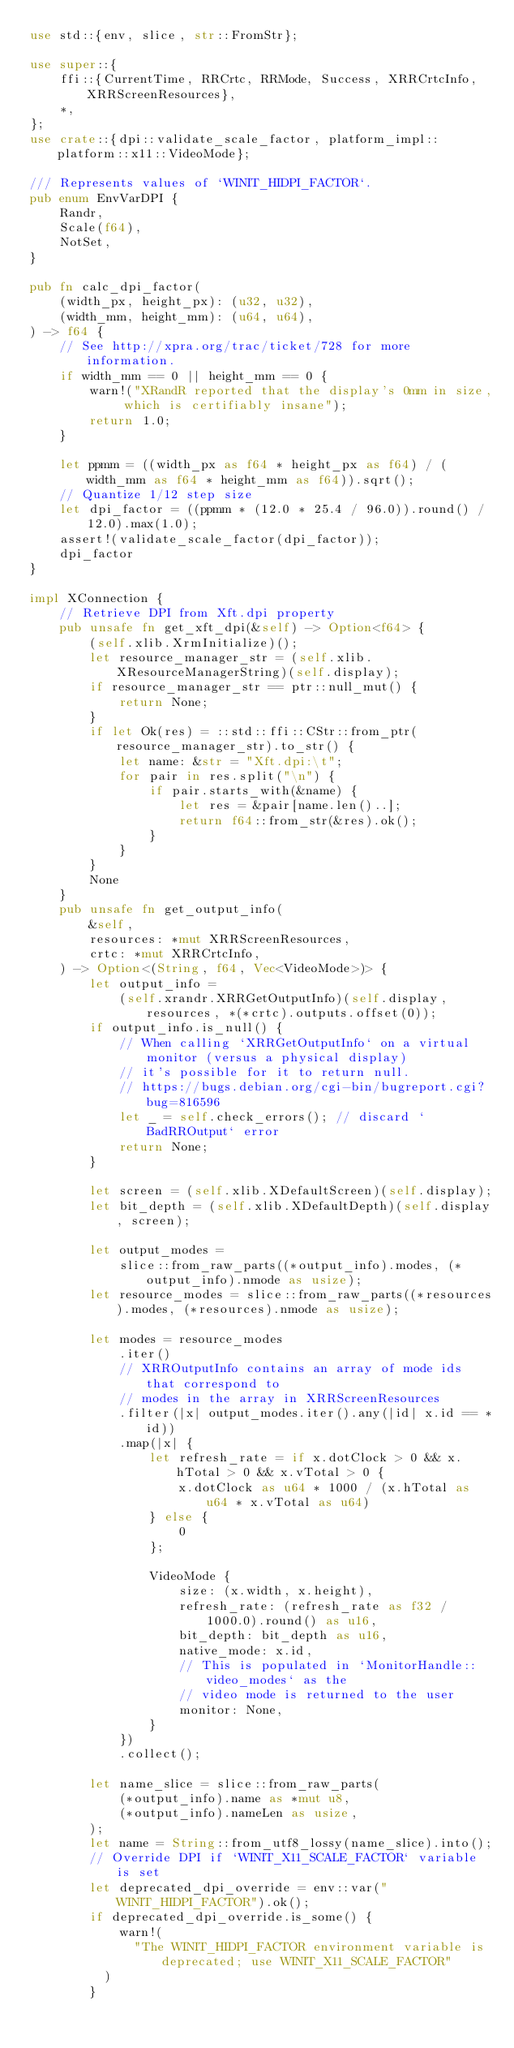<code> <loc_0><loc_0><loc_500><loc_500><_Rust_>use std::{env, slice, str::FromStr};

use super::{
    ffi::{CurrentTime, RRCrtc, RRMode, Success, XRRCrtcInfo, XRRScreenResources},
    *,
};
use crate::{dpi::validate_scale_factor, platform_impl::platform::x11::VideoMode};

/// Represents values of `WINIT_HIDPI_FACTOR`.
pub enum EnvVarDPI {
    Randr,
    Scale(f64),
    NotSet,
}

pub fn calc_dpi_factor(
    (width_px, height_px): (u32, u32),
    (width_mm, height_mm): (u64, u64),
) -> f64 {
    // See http://xpra.org/trac/ticket/728 for more information.
    if width_mm == 0 || height_mm == 0 {
        warn!("XRandR reported that the display's 0mm in size, which is certifiably insane");
        return 1.0;
    }

    let ppmm = ((width_px as f64 * height_px as f64) / (width_mm as f64 * height_mm as f64)).sqrt();
    // Quantize 1/12 step size
    let dpi_factor = ((ppmm * (12.0 * 25.4 / 96.0)).round() / 12.0).max(1.0);
    assert!(validate_scale_factor(dpi_factor));
    dpi_factor
}

impl XConnection {
    // Retrieve DPI from Xft.dpi property
    pub unsafe fn get_xft_dpi(&self) -> Option<f64> {
        (self.xlib.XrmInitialize)();
        let resource_manager_str = (self.xlib.XResourceManagerString)(self.display);
        if resource_manager_str == ptr::null_mut() {
            return None;
        }
        if let Ok(res) = ::std::ffi::CStr::from_ptr(resource_manager_str).to_str() {
            let name: &str = "Xft.dpi:\t";
            for pair in res.split("\n") {
                if pair.starts_with(&name) {
                    let res = &pair[name.len()..];
                    return f64::from_str(&res).ok();
                }
            }
        }
        None
    }
    pub unsafe fn get_output_info(
        &self,
        resources: *mut XRRScreenResources,
        crtc: *mut XRRCrtcInfo,
    ) -> Option<(String, f64, Vec<VideoMode>)> {
        let output_info =
            (self.xrandr.XRRGetOutputInfo)(self.display, resources, *(*crtc).outputs.offset(0));
        if output_info.is_null() {
            // When calling `XRRGetOutputInfo` on a virtual monitor (versus a physical display)
            // it's possible for it to return null.
            // https://bugs.debian.org/cgi-bin/bugreport.cgi?bug=816596
            let _ = self.check_errors(); // discard `BadRROutput` error
            return None;
        }

        let screen = (self.xlib.XDefaultScreen)(self.display);
        let bit_depth = (self.xlib.XDefaultDepth)(self.display, screen);

        let output_modes =
            slice::from_raw_parts((*output_info).modes, (*output_info).nmode as usize);
        let resource_modes = slice::from_raw_parts((*resources).modes, (*resources).nmode as usize);

        let modes = resource_modes
            .iter()
            // XRROutputInfo contains an array of mode ids that correspond to
            // modes in the array in XRRScreenResources
            .filter(|x| output_modes.iter().any(|id| x.id == *id))
            .map(|x| {
                let refresh_rate = if x.dotClock > 0 && x.hTotal > 0 && x.vTotal > 0 {
                    x.dotClock as u64 * 1000 / (x.hTotal as u64 * x.vTotal as u64)
                } else {
                    0
                };

                VideoMode {
                    size: (x.width, x.height),
                    refresh_rate: (refresh_rate as f32 / 1000.0).round() as u16,
                    bit_depth: bit_depth as u16,
                    native_mode: x.id,
                    // This is populated in `MonitorHandle::video_modes` as the
                    // video mode is returned to the user
                    monitor: None,
                }
            })
            .collect();

        let name_slice = slice::from_raw_parts(
            (*output_info).name as *mut u8,
            (*output_info).nameLen as usize,
        );
        let name = String::from_utf8_lossy(name_slice).into();
        // Override DPI if `WINIT_X11_SCALE_FACTOR` variable is set
        let deprecated_dpi_override = env::var("WINIT_HIDPI_FACTOR").ok();
        if deprecated_dpi_override.is_some() {
            warn!(
	            "The WINIT_HIDPI_FACTOR environment variable is deprecated; use WINIT_X11_SCALE_FACTOR"
	        )
        }</code> 